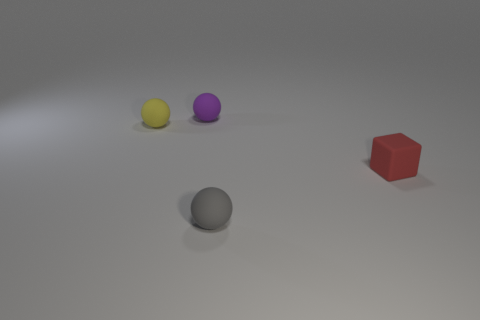What is the color of the block?
Offer a very short reply. Red. The rubber sphere in front of the red matte block is what color?
Keep it short and to the point. Gray. What number of purple things are in front of the small matte sphere behind the tiny yellow object?
Offer a very short reply. 0. Are there any other yellow matte objects that have the same size as the yellow rubber object?
Offer a very short reply. No. What number of objects are either small gray spheres or rubber spheres?
Provide a short and direct response. 3. Is there a tiny yellow rubber thing that has the same shape as the small gray thing?
Offer a terse response. Yes. Are there fewer tiny rubber balls that are behind the red cube than objects?
Your response must be concise. Yes. Is the tiny gray object the same shape as the purple matte thing?
Keep it short and to the point. Yes. Are there fewer tiny yellow rubber spheres than small objects?
Your answer should be very brief. Yes. There is a red block that is the same size as the gray ball; what is its material?
Your answer should be compact. Rubber. 